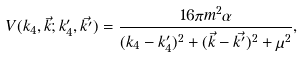Convert formula to latex. <formula><loc_0><loc_0><loc_500><loc_500>V ( k _ { 4 } , \vec { k } ; k _ { 4 } ^ { \prime } , \vec { k ^ { \prime } } ) = \frac { 1 6 \pi m ^ { 2 } \alpha } { ( k _ { 4 } - k ^ { \prime } _ { 4 } ) ^ { 2 } + ( \vec { k } - \vec { k ^ { \prime } } ) ^ { 2 } + \mu ^ { 2 } } ,</formula> 